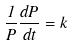Convert formula to latex. <formula><loc_0><loc_0><loc_500><loc_500>\frac { 1 } { P } \frac { d P } { d t } = k</formula> 